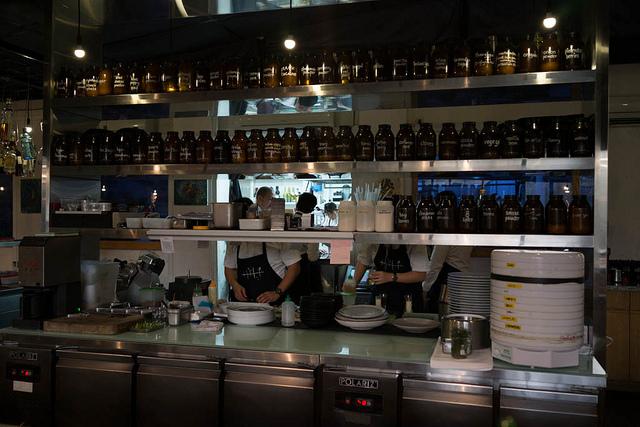What are the shelves made of?
Answer briefly. Metal. What are most of the people using?
Quick response, please. Plates. What color is the largest appliance?
Be succinct. Silver. Is this a professional restaurant?
Quick response, please. Yes. Is this a place to prepare food?
Quick response, please. Yes. 